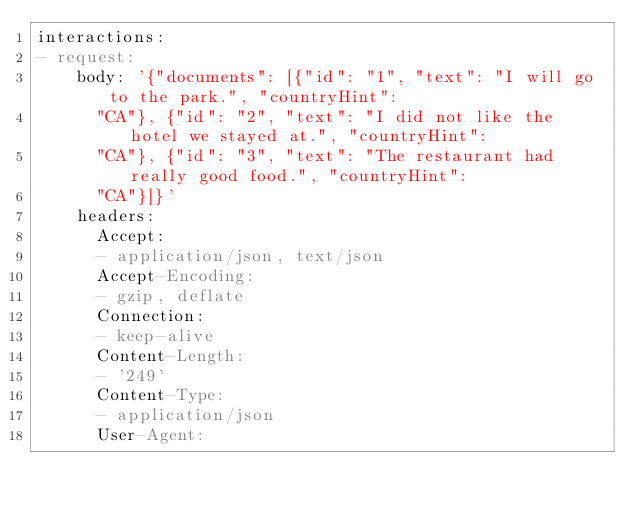Convert code to text. <code><loc_0><loc_0><loc_500><loc_500><_YAML_>interactions:
- request:
    body: '{"documents": [{"id": "1", "text": "I will go to the park.", "countryHint":
      "CA"}, {"id": "2", "text": "I did not like the hotel we stayed at.", "countryHint":
      "CA"}, {"id": "3", "text": "The restaurant had really good food.", "countryHint":
      "CA"}]}'
    headers:
      Accept:
      - application/json, text/json
      Accept-Encoding:
      - gzip, deflate
      Connection:
      - keep-alive
      Content-Length:
      - '249'
      Content-Type:
      - application/json
      User-Agent:</code> 